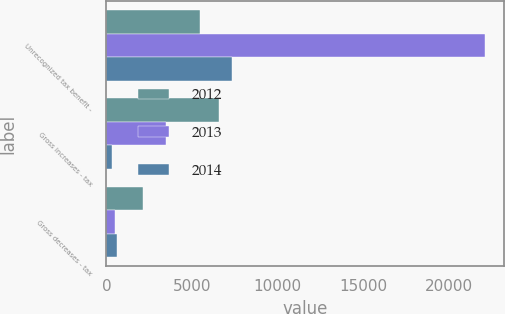Convert chart to OTSL. <chart><loc_0><loc_0><loc_500><loc_500><stacked_bar_chart><ecel><fcel>Unrecognized tax benefit -<fcel>Gross increases - tax<fcel>Gross decreases - tax<nl><fcel>2012<fcel>5496<fcel>6569<fcel>2164<nl><fcel>2013<fcel>22104<fcel>3507<fcel>495<nl><fcel>2014<fcel>7343<fcel>343<fcel>615<nl></chart> 